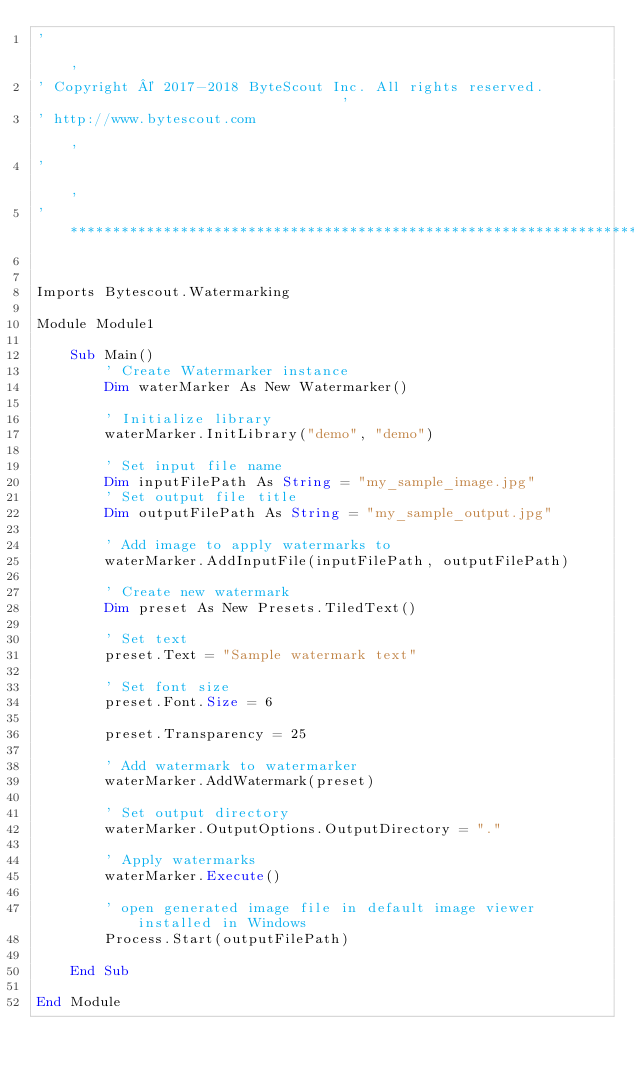Convert code to text. <code><loc_0><loc_0><loc_500><loc_500><_VisualBasic_>'                                                                                           '
' Copyright © 2017-2018 ByteScout Inc. All rights reserved.                                 '
' http://www.bytescout.com                                                                  '
'                                                                                           '
'*******************************************************************************************'


Imports Bytescout.Watermarking

Module Module1

    Sub Main()
        ' Create Watermarker instance
        Dim waterMarker As New Watermarker()

        ' Initialize library
        waterMarker.InitLibrary("demo", "demo")

        ' Set input file name
        Dim inputFilePath As String = "my_sample_image.jpg"
        ' Set output file title
        Dim outputFilePath As String = "my_sample_output.jpg"

        ' Add image to apply watermarks to
        waterMarker.AddInputFile(inputFilePath, outputFilePath)

        ' Create new watermark
        Dim preset As New Presets.TiledText()

        ' Set text
        preset.Text = "Sample watermark text"

        ' Set font size
        preset.Font.Size = 6

        preset.Transparency = 25

        ' Add watermark to watermarker
        waterMarker.AddWatermark(preset)

        ' Set output directory
        waterMarker.OutputOptions.OutputDirectory = "."

        ' Apply watermarks
        waterMarker.Execute()

        ' open generated image file in default image viewer installed in Windows
        Process.Start(outputFilePath)

    End Sub

End Module
</code> 